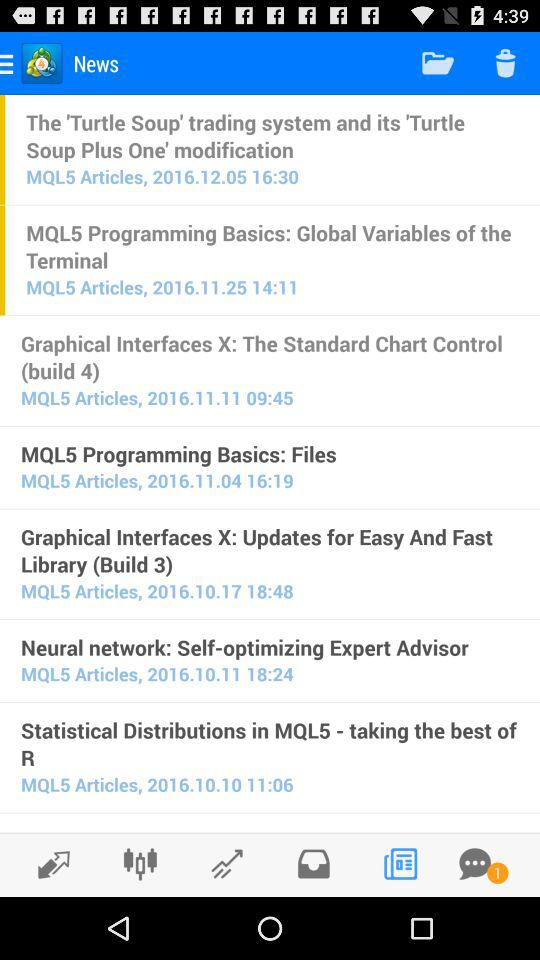How many items are in the trash?
When the provided information is insufficient, respond with <no answer>. <no answer> 